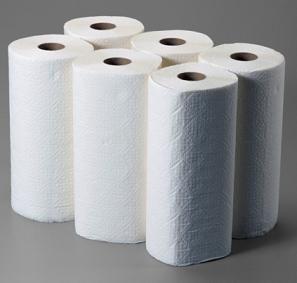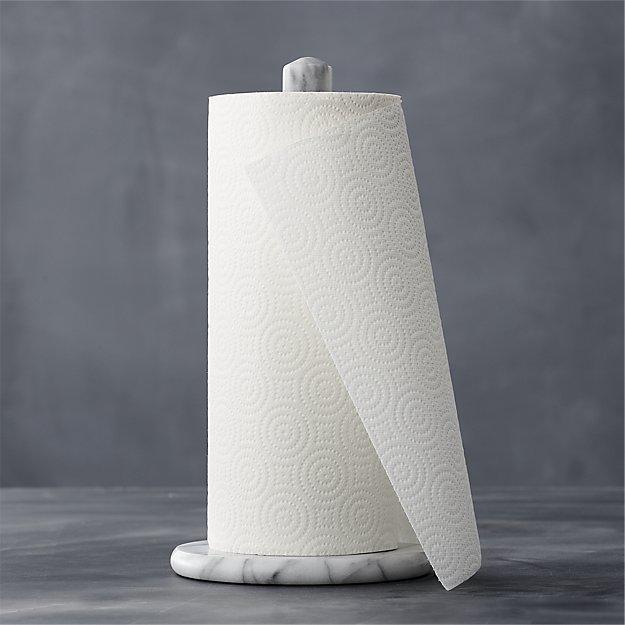The first image is the image on the left, the second image is the image on the right. Considering the images on both sides, is "One image shows white paper towels that are not in roll format." valid? Answer yes or no. No. 